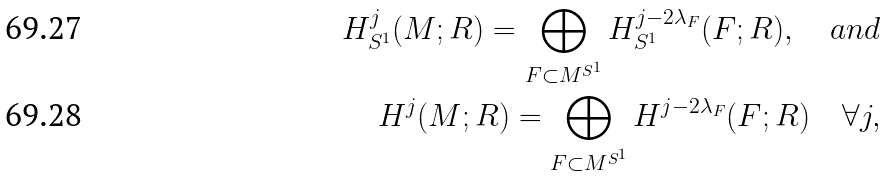<formula> <loc_0><loc_0><loc_500><loc_500>H _ { S ^ { 1 } } ^ { j } ( M ; R ) = \bigoplus _ { F \subset M ^ { S ^ { 1 } } } H _ { S ^ { 1 } } ^ { j - 2 \lambda _ { F } } ( F ; R ) , \quad a n d \\ H ^ { j } ( M ; R ) = \bigoplus _ { F \subset M ^ { S ^ { 1 } } } H ^ { j - 2 \lambda _ { F } } ( F ; R ) \quad \forall j ,</formula> 